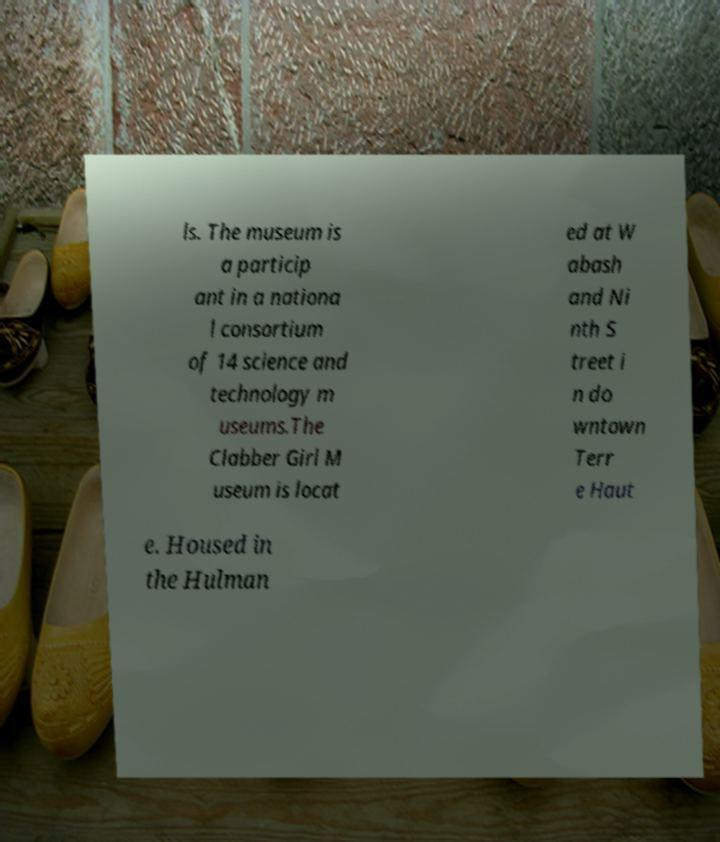For documentation purposes, I need the text within this image transcribed. Could you provide that? ls. The museum is a particip ant in a nationa l consortium of 14 science and technology m useums.The Clabber Girl M useum is locat ed at W abash and Ni nth S treet i n do wntown Terr e Haut e. Housed in the Hulman 